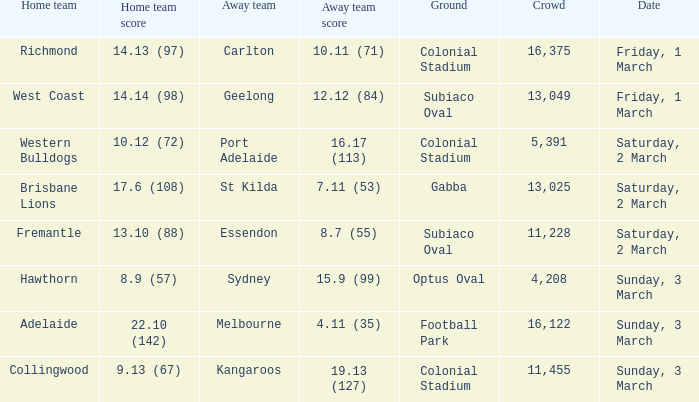Who is the opponent when the home team achieved 1 St Kilda. 